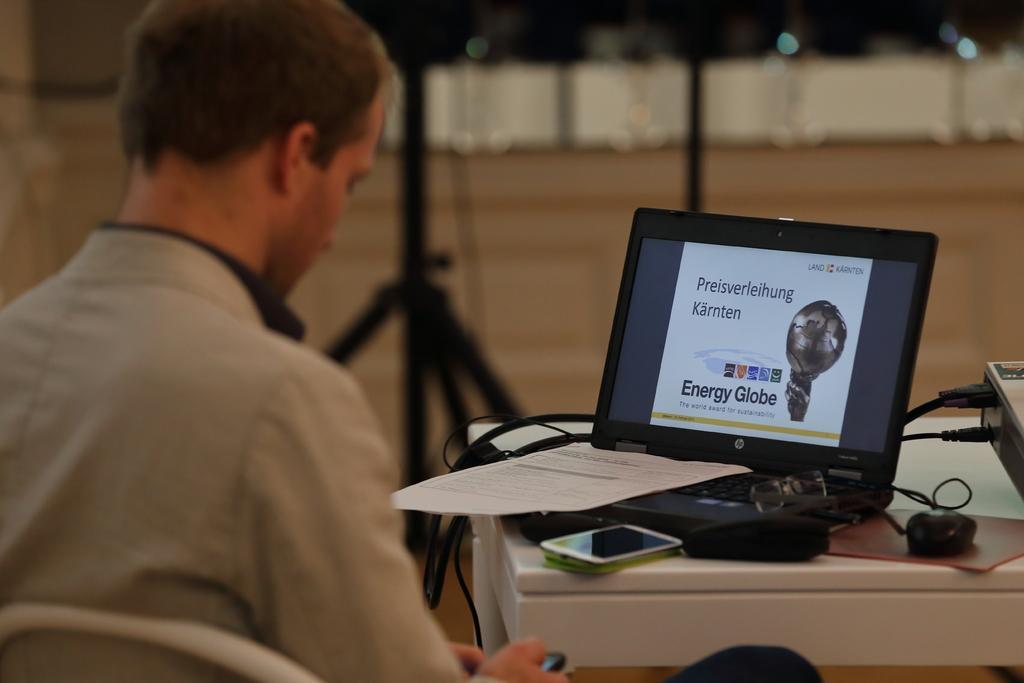How would you summarize this image in a sentence or two? This person is sitting on a chair. In-front of this person there is a table, on a table there is a laptop, paper, mobile, mouse and projector. Far there is a pole. 